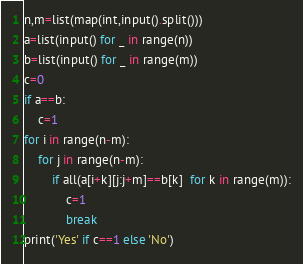<code> <loc_0><loc_0><loc_500><loc_500><_Python_>n,m=list(map(int,input().split()))
a=list(input() for _ in range(n))
b=list(input() for _ in range(m))
c=0
if a==b:
    c=1
for i in range(n-m):
    for j in range(n-m):
        if all(a[i+k][j:j+m]==b[k]  for k in range(m)):
            c=1
            break
print('Yes' if c==1 else 'No')</code> 